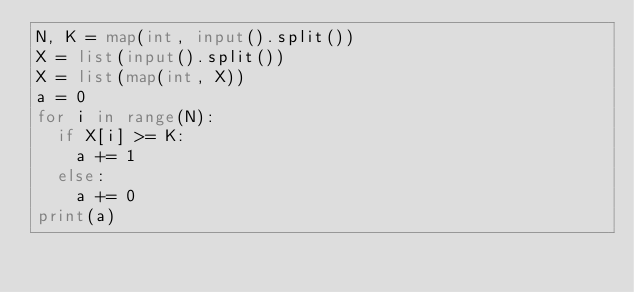Convert code to text. <code><loc_0><loc_0><loc_500><loc_500><_Python_>N, K = map(int, input().split())
X = list(input().split())
X = list(map(int, X))
a = 0
for i in range(N):
  if X[i] >= K:
    a += 1
  else:
    a += 0
print(a)</code> 